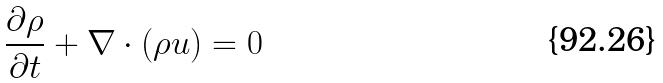<formula> <loc_0><loc_0><loc_500><loc_500>\frac { \partial \rho } { \partial t } + \nabla \cdot ( \rho u ) = 0</formula> 